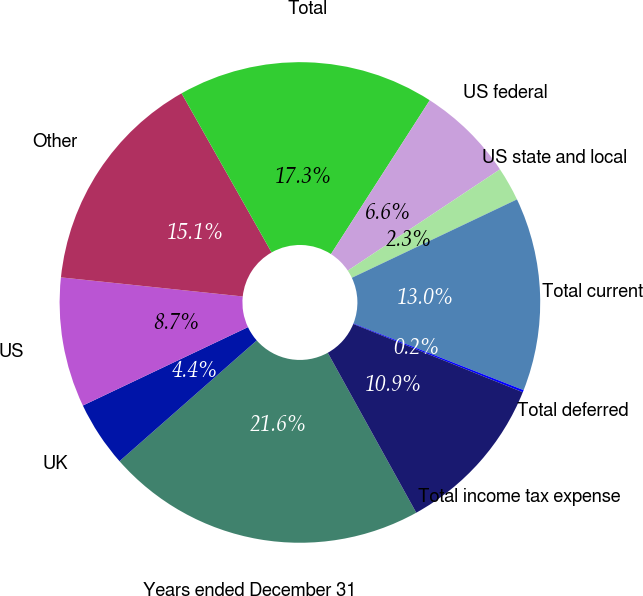Convert chart. <chart><loc_0><loc_0><loc_500><loc_500><pie_chart><fcel>Years ended December 31<fcel>UK<fcel>US<fcel>Other<fcel>Total<fcel>US federal<fcel>US state and local<fcel>Total current<fcel>Total deferred<fcel>Total income tax expense<nl><fcel>21.56%<fcel>4.43%<fcel>8.72%<fcel>15.14%<fcel>17.28%<fcel>6.57%<fcel>2.29%<fcel>13.0%<fcel>0.15%<fcel>10.86%<nl></chart> 